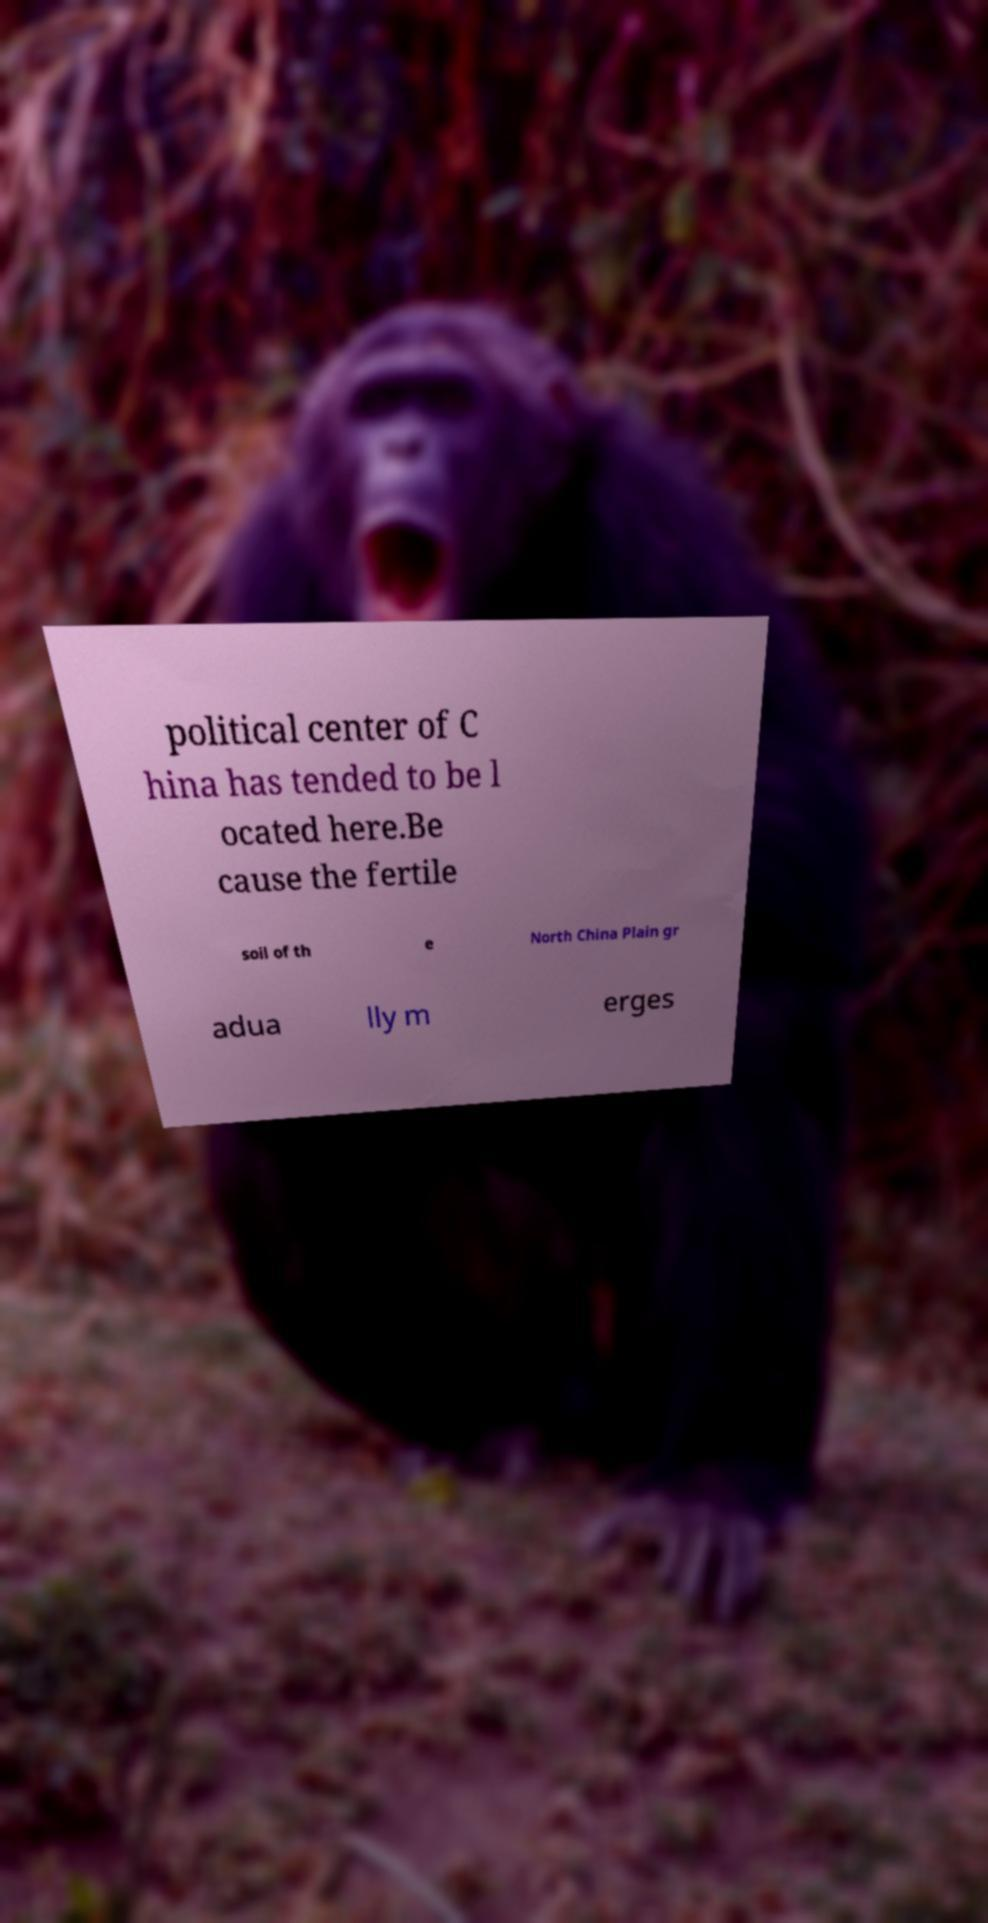Can you accurately transcribe the text from the provided image for me? political center of C hina has tended to be l ocated here.Be cause the fertile soil of th e North China Plain gr adua lly m erges 